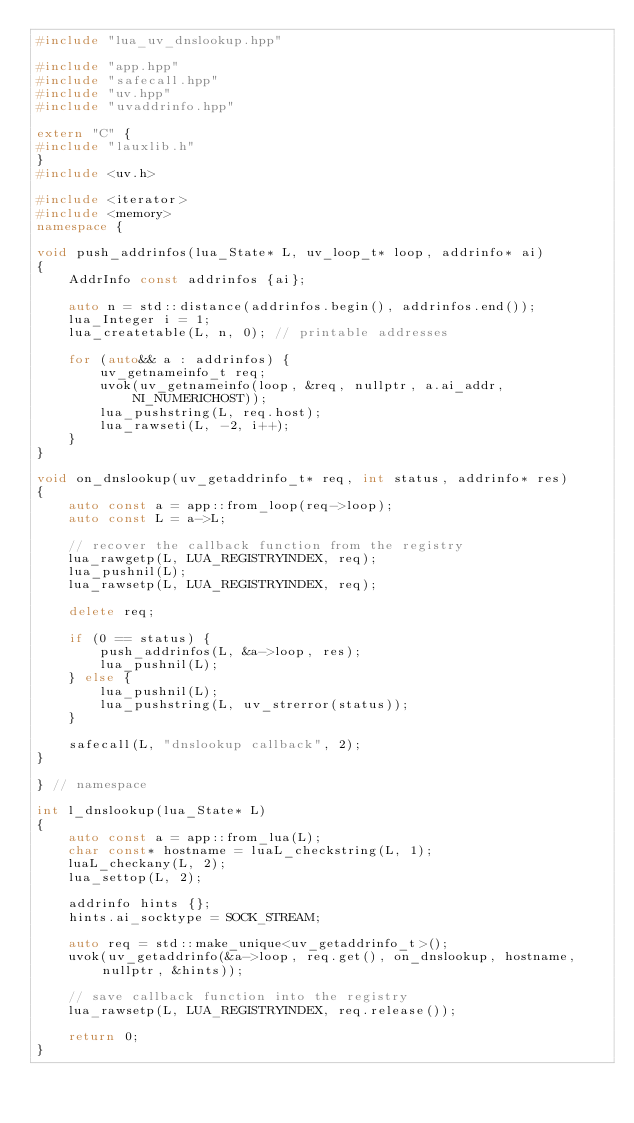Convert code to text. <code><loc_0><loc_0><loc_500><loc_500><_C++_>#include "lua_uv_dnslookup.hpp"

#include "app.hpp"
#include "safecall.hpp"
#include "uv.hpp"
#include "uvaddrinfo.hpp"

extern "C" {
#include "lauxlib.h"
}
#include <uv.h>

#include <iterator>
#include <memory>
namespace {

void push_addrinfos(lua_State* L, uv_loop_t* loop, addrinfo* ai)
{
    AddrInfo const addrinfos {ai};

    auto n = std::distance(addrinfos.begin(), addrinfos.end());
    lua_Integer i = 1;
    lua_createtable(L, n, 0); // printable addresses

    for (auto&& a : addrinfos) {
        uv_getnameinfo_t req;
        uvok(uv_getnameinfo(loop, &req, nullptr, a.ai_addr, NI_NUMERICHOST));
        lua_pushstring(L, req.host);
        lua_rawseti(L, -2, i++);
    }
}

void on_dnslookup(uv_getaddrinfo_t* req, int status, addrinfo* res)
{
    auto const a = app::from_loop(req->loop);
    auto const L = a->L;

    // recover the callback function from the registry
    lua_rawgetp(L, LUA_REGISTRYINDEX, req);
    lua_pushnil(L);
    lua_rawsetp(L, LUA_REGISTRYINDEX, req);

    delete req;

    if (0 == status) {
        push_addrinfos(L, &a->loop, res);
        lua_pushnil(L);
    } else {
        lua_pushnil(L);
        lua_pushstring(L, uv_strerror(status));
    }

    safecall(L, "dnslookup callback", 2);
}

} // namespace

int l_dnslookup(lua_State* L)
{
    auto const a = app::from_lua(L);
    char const* hostname = luaL_checkstring(L, 1);
    luaL_checkany(L, 2);
    lua_settop(L, 2);

    addrinfo hints {};
    hints.ai_socktype = SOCK_STREAM;

    auto req = std::make_unique<uv_getaddrinfo_t>();
    uvok(uv_getaddrinfo(&a->loop, req.get(), on_dnslookup, hostname, nullptr, &hints));

    // save callback function into the registry
    lua_rawsetp(L, LUA_REGISTRYINDEX, req.release());

    return 0;
}
</code> 